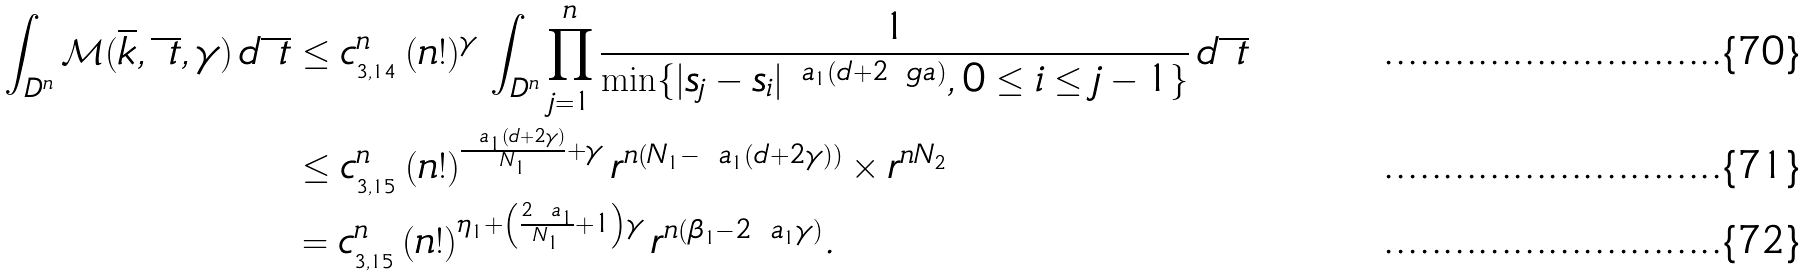<formula> <loc_0><loc_0><loc_500><loc_500>\int _ { D ^ { n } } \mathcal { M } ( \overline { k } , \overline { \ t } , \gamma ) \, d \overline { \ t } & \leq c _ { _ { 3 , 1 4 } } ^ { n } \, ( n ! ) ^ { \gamma } \, \int _ { D ^ { n } } \prod _ { j = 1 } ^ { n } \frac { 1 } { \min \{ | s _ { j } - s _ { i } | ^ { \ a _ { 1 } ( d + 2 \ g a ) } , 0 \leq i \leq j - 1 \} } \, d \overline { \ t } \\ & \leq c _ { _ { 3 , 1 5 } } ^ { n } \, ( n ! ) ^ { \frac { \ a _ { 1 } ( d + 2 \gamma ) } { N _ { 1 } } + \gamma } \, r ^ { n \left ( N _ { 1 } - \ a _ { 1 } ( d + 2 \gamma ) \right ) } \times r ^ { n N _ { 2 } } \\ & = c _ { _ { 3 , 1 5 } } ^ { n } \, ( n ! ) ^ { \eta _ { 1 } + \left ( \frac { 2 \ a _ { 1 } } { N _ { 1 } } + 1 \right ) \gamma } \, r ^ { n ( \beta _ { 1 } - 2 \ a _ { 1 } \gamma ) } .</formula> 